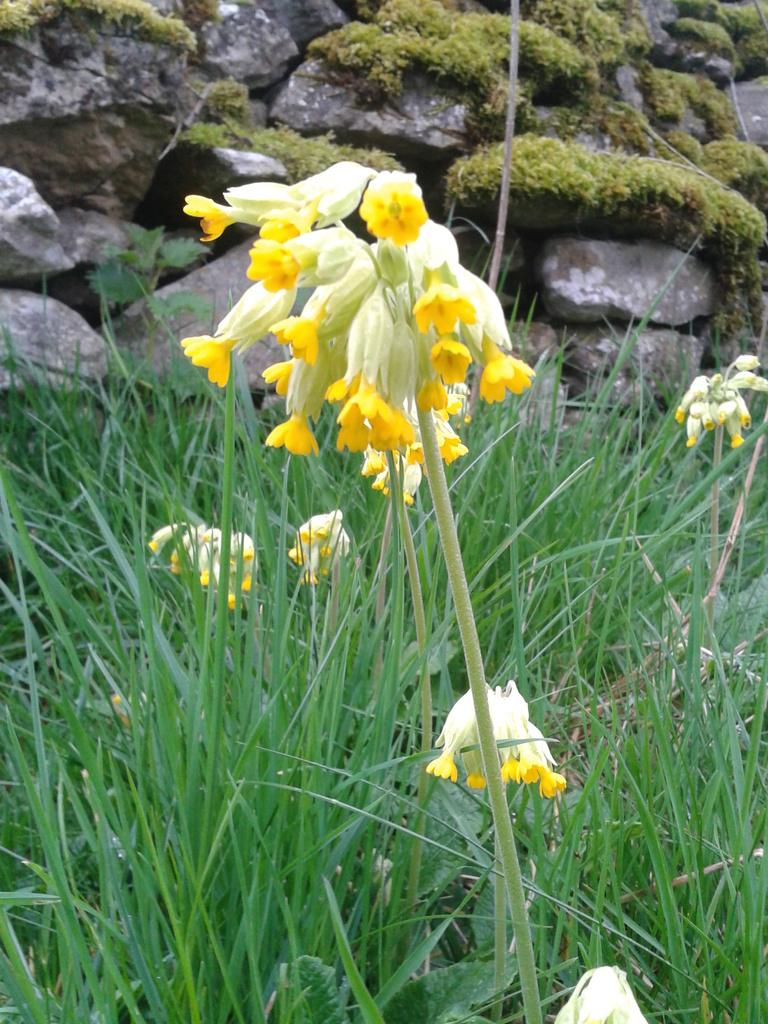What is the main subject in the middle of the image? There is a yellow flower plant in the middle of the image. What type of vegetation covers the land in the image? There is grass all over the land in the image. What can be seen in the background of the image? There are rocks with plants over them in the background of the image. What type of insurance policy is being advertised on the back of the yellow flower plant? There is no insurance policy or advertisement present in the image; it features a yellow flower plant, grass, and rocks with plants in the background. 